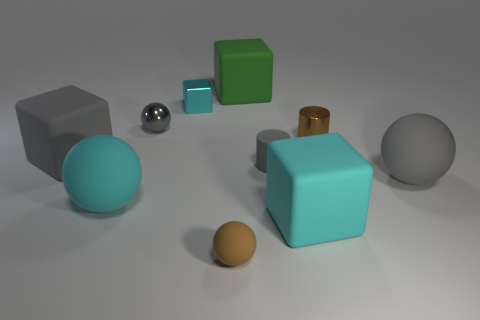Subtract all gray balls. How many were subtracted if there are1gray balls left? 1 Subtract 1 cubes. How many cubes are left? 3 Subtract all tiny cyan metallic cubes. How many cubes are left? 3 Subtract all blue cubes. Subtract all gray balls. How many cubes are left? 4 Subtract all cylinders. How many objects are left? 8 Add 5 tiny gray objects. How many tiny gray objects exist? 7 Subtract 1 brown spheres. How many objects are left? 9 Subtract all green rubber cubes. Subtract all brown objects. How many objects are left? 7 Add 3 tiny gray rubber things. How many tiny gray rubber things are left? 4 